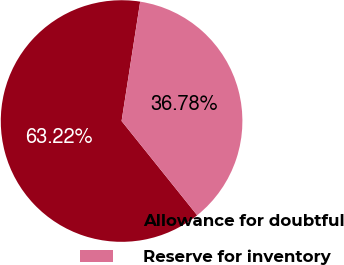Convert chart to OTSL. <chart><loc_0><loc_0><loc_500><loc_500><pie_chart><fcel>Allowance for doubtful<fcel>Reserve for inventory<nl><fcel>63.22%<fcel>36.78%<nl></chart> 